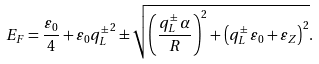Convert formula to latex. <formula><loc_0><loc_0><loc_500><loc_500>E _ { F } = \frac { \varepsilon _ { 0 } } { 4 } + \varepsilon _ { 0 } { q _ { L } ^ { \pm } } ^ { 2 } \pm \sqrt { \left ( \frac { { q _ { L } ^ { \pm } } \, { \alpha } } { R } \right ) ^ { 2 } + { \left ( { q _ { L } ^ { \pm } } \, { \varepsilon _ { 0 } } + { \varepsilon _ { Z } } \right ) } ^ { 2 } } .</formula> 